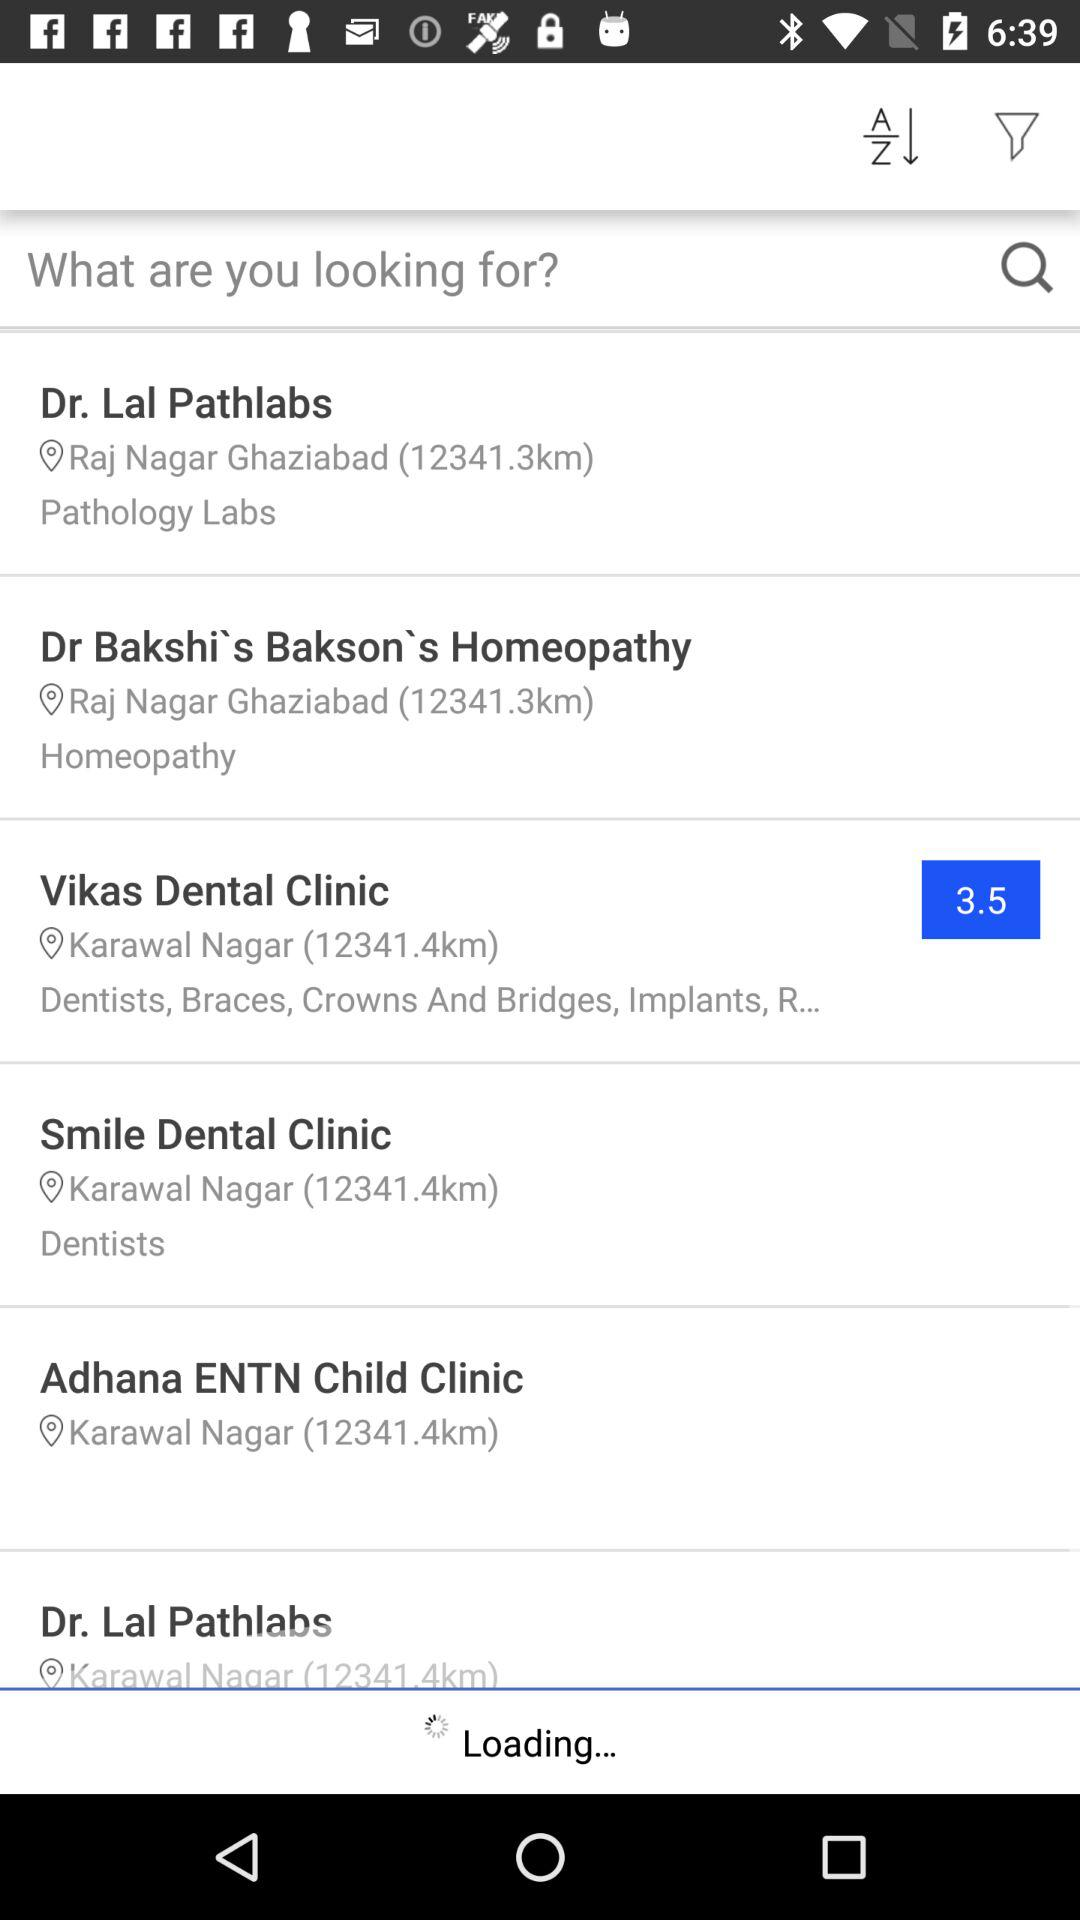In which town is "Smile Dental Clinic" located? "Smile Dental Clinic" is located in Karawal Nagar town. 